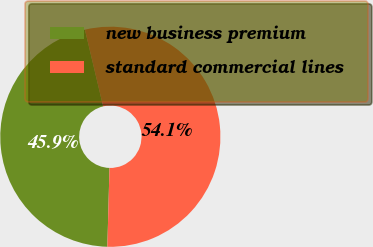<chart> <loc_0><loc_0><loc_500><loc_500><pie_chart><fcel>new business premium<fcel>standard commercial lines<nl><fcel>45.86%<fcel>54.14%<nl></chart> 